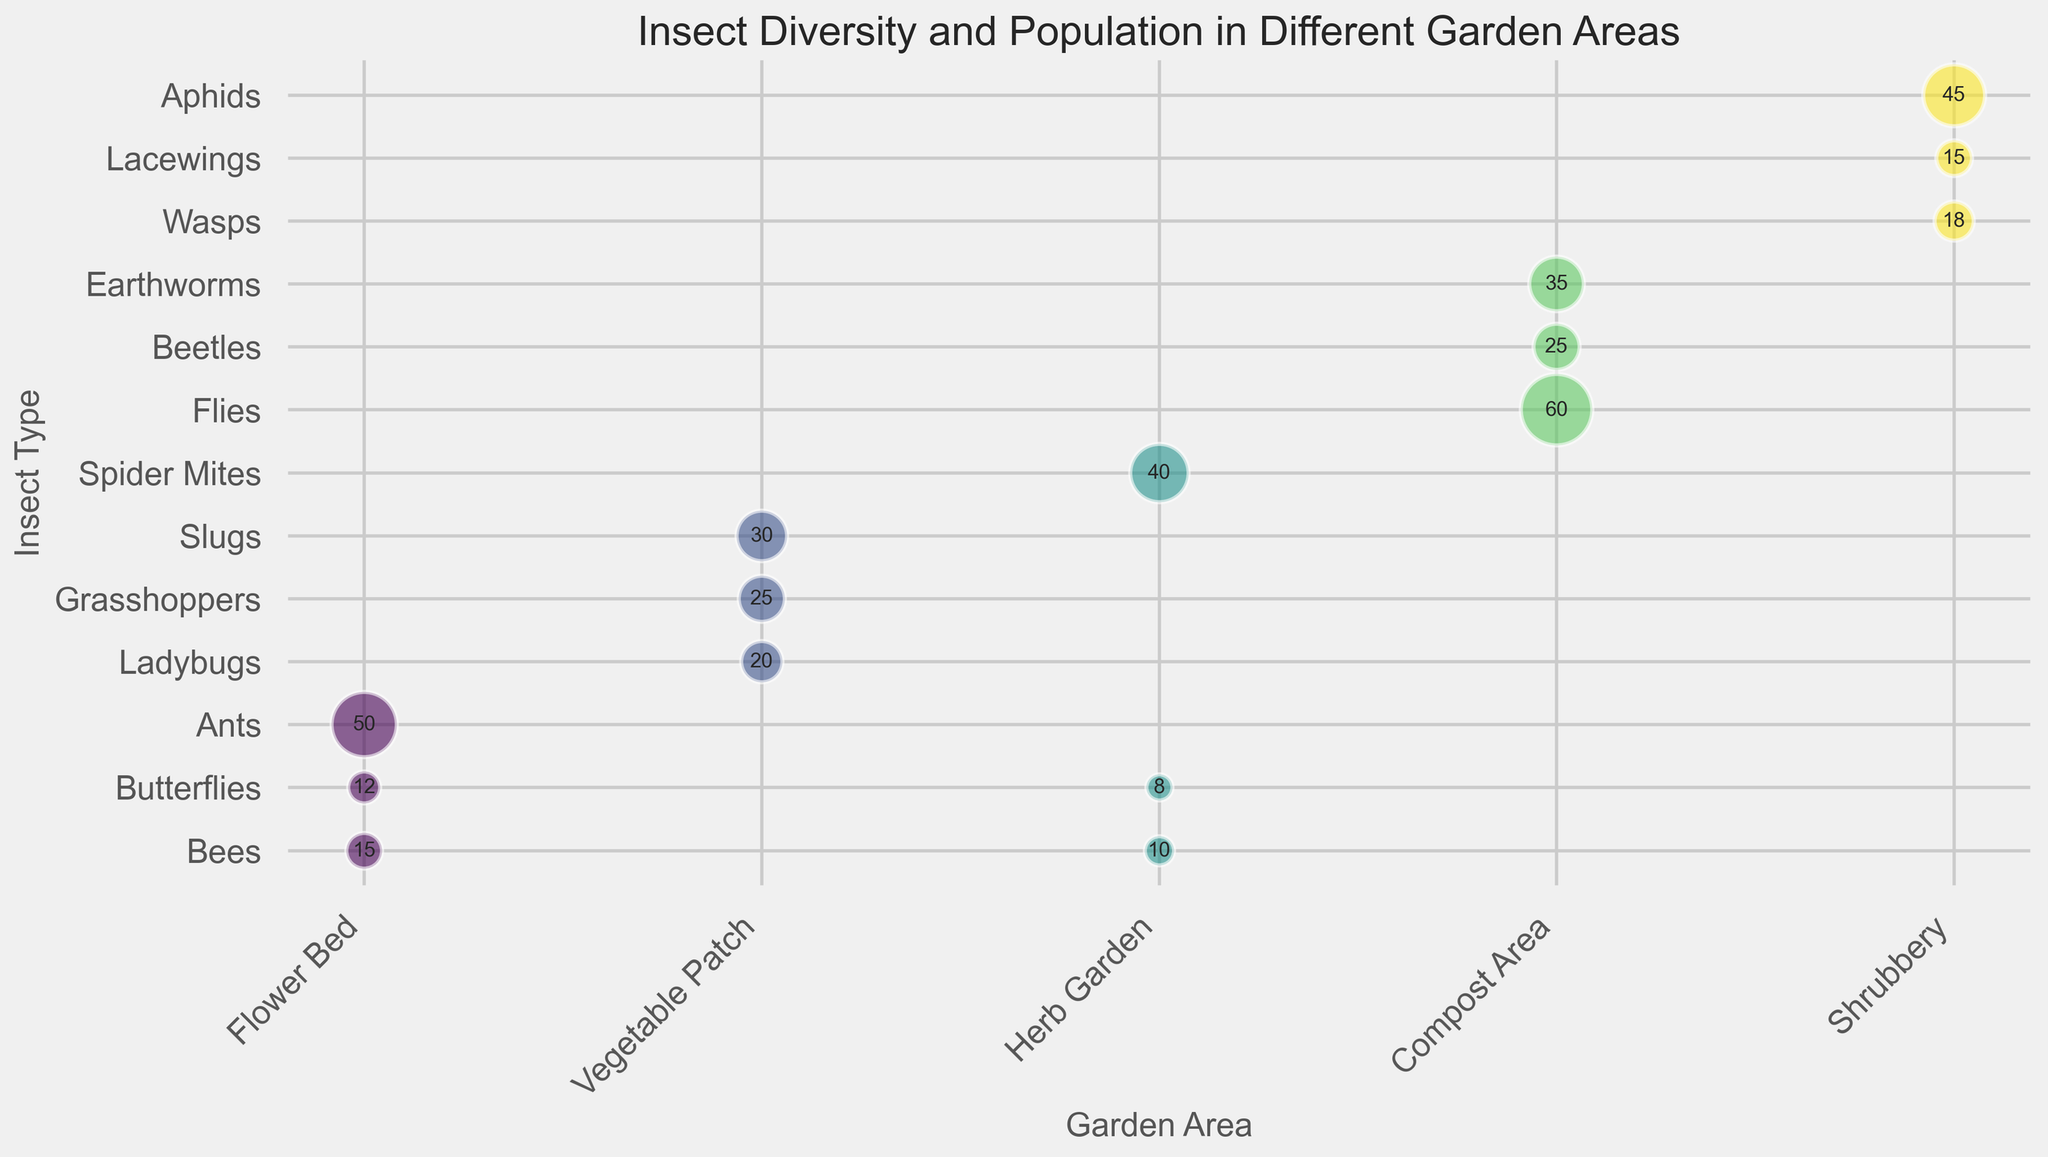What is the total population of Bees across all garden areas? Look at the bubbles and labels representing Bees in each garden area and sum their populations: Flower Bed (15) + Herb Garden (10) = 25
Answer: 25 Which insect type has the highest population in the Compost Area? Identify the bubble with the largest size in the Compost Area and check its label: Earthworms (35)
Answer: Earthworms In which garden area is the population of Butterflies higher, the Flower Bed or the Herb Garden? Compare the population numbers of Butterflies in these areas: Flower Bed (12) and Herb Garden (8). The larger number is in the Flower Bed.
Answer: Flower Bed Which insect type in the Shrubbery has the lowest population? Identify the insect type with the smallest bubble in the Shrubbery area and check its label: Lacewings (15)
Answer: Lacewings How does the population of ants in the Flower Bed compare to the population of slugs in the Vegetable Patch? Compare the two populations: Ants (50) and Slugs (30). Ants have a higher population.
Answer: Ants have a higher population What is the average importance level for insects in the Vegetable Patch? Sum the importance levels in the Vegetable Patch and divide by the number of insect types in this area: (9 + 5 + 4) / 3 = 18 / 3 = 6
Answer: 6 Which garden area has the most insect types with a population greater than 30? Identify insect populations over 30 and count them for each area. Compost Area (Flies 60, Earthworms 35), Vegetable Patch (Slugs 30), Flower Bed (Ants 50), Shrubbery (Aphids 45), Herb Garden (Spider Mites 40). Compost Area has 2, the others have 1 each
Answer: Compost Area What is the combined population of aphids and lacewings in the Shrubbery? Look at the populations for Aphids (45) and Lacewings (15) and add them up: 45 + 15 = 60
Answer: 60 